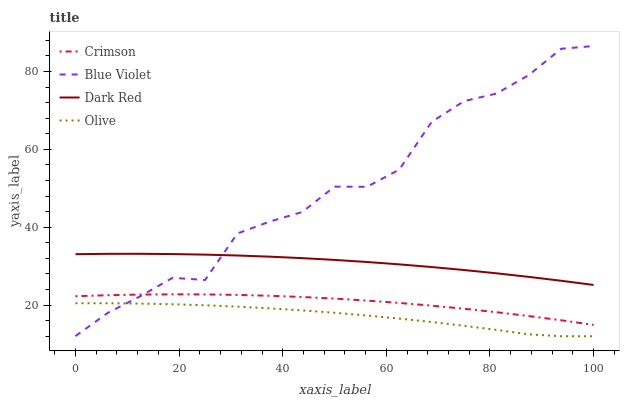Does Dark Red have the minimum area under the curve?
Answer yes or no. No. Does Dark Red have the maximum area under the curve?
Answer yes or no. No. Is Blue Violet the smoothest?
Answer yes or no. No. Is Dark Red the roughest?
Answer yes or no. No. Does Blue Violet have the lowest value?
Answer yes or no. No. Does Dark Red have the highest value?
Answer yes or no. No. Is Crimson less than Dark Red?
Answer yes or no. Yes. Is Dark Red greater than Olive?
Answer yes or no. Yes. Does Crimson intersect Dark Red?
Answer yes or no. No. 